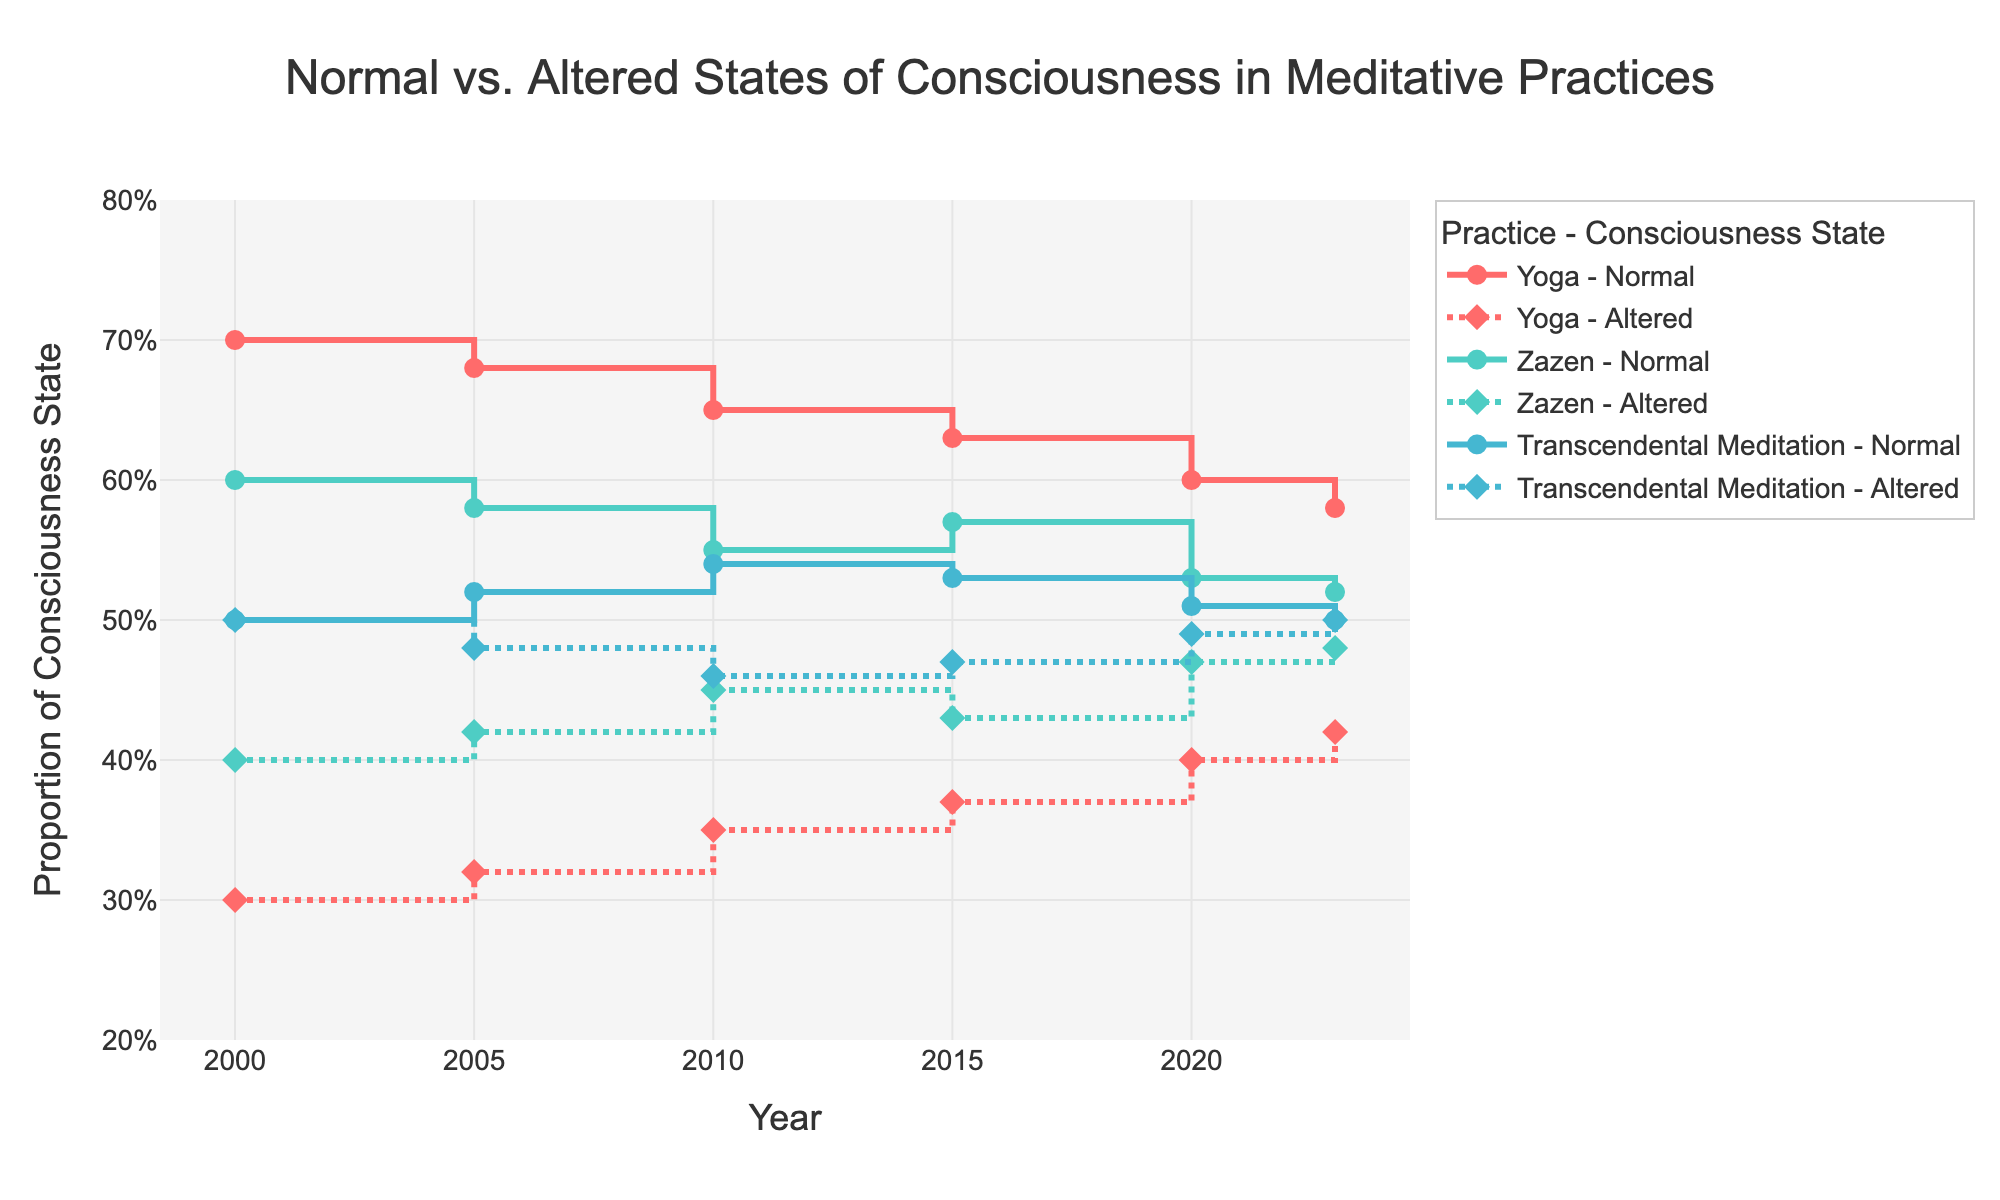What's the title of the plot? The title of the plot is positioned at the top center and provides a brief description of what the plot represents.
Answer: Normal vs. Altered States of Consciousness in Meditative Practices How many meditative practices are represented in the plot? The plot legend and the traces in the plot show distinct lines for each meditative practice. You can count these distinct categories.
Answer: 3 Which meditative practice shows the highest proportion of altered states of consciousness in the year 2023? Look for lines marked with diamond symbols indicating altered states in 2023, and find the corresponding highest value.
Answer: Transcendental Meditation What is the trend in the proportion of normal states of consciousness for Yoga from 2000 to 2023? Examine the line for Yoga with circle symbols, marking normal states over the years from 2000 to 2023. Observe if the line is generally increasing, decreasing, or remaining stable.
Answer: Decreasing Between 2000 and 2023, which meditative practice shows the most significant increase in altered states of consciousness? Identify the lines with diamond symbols for each practice and note the change for altered states from 2000 to 2023. Compare these changes.
Answer: Zazen What is the difference in the proportion of altered states of consciousness between Transcendental Meditation and Zazen in the year 2010? Find the proportions for altered states for both practices in 2010 and calculate the difference.
Answer: 0.01 Compare the trend of normal states of consciousness in Zazen and Transcendental Meditation from 2000 to 2023. Which one shows a more significant decrease? Observe the lines for normal states (circle symbols) for both Zazen and Transcendental Meditation. Determine which line shows a steeper decline.
Answer: Zazen What is the average proportion of altered states of consciousness for Yoga across all years shown? Sum the proportions of altered states for Yoga from each year and divide by the number of years (6).
Answer: 0.37 By 2023, which meditative practice has the closest ratio of normal to altered states of consciousness? Examine the 2023 data points for the ratio of normal (circle symbols) to altered (diamond symbols) states in each practice and find the closest to 1:1.
Answer: Transcendental Meditation 